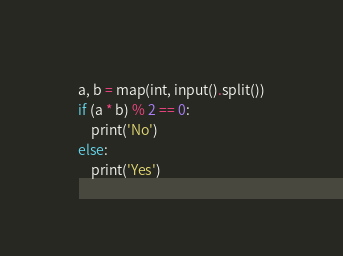Convert code to text. <code><loc_0><loc_0><loc_500><loc_500><_Python_>a, b = map(int, input().split())
if (a * b) % 2 == 0:
    print('No')
else:
    print('Yes')</code> 